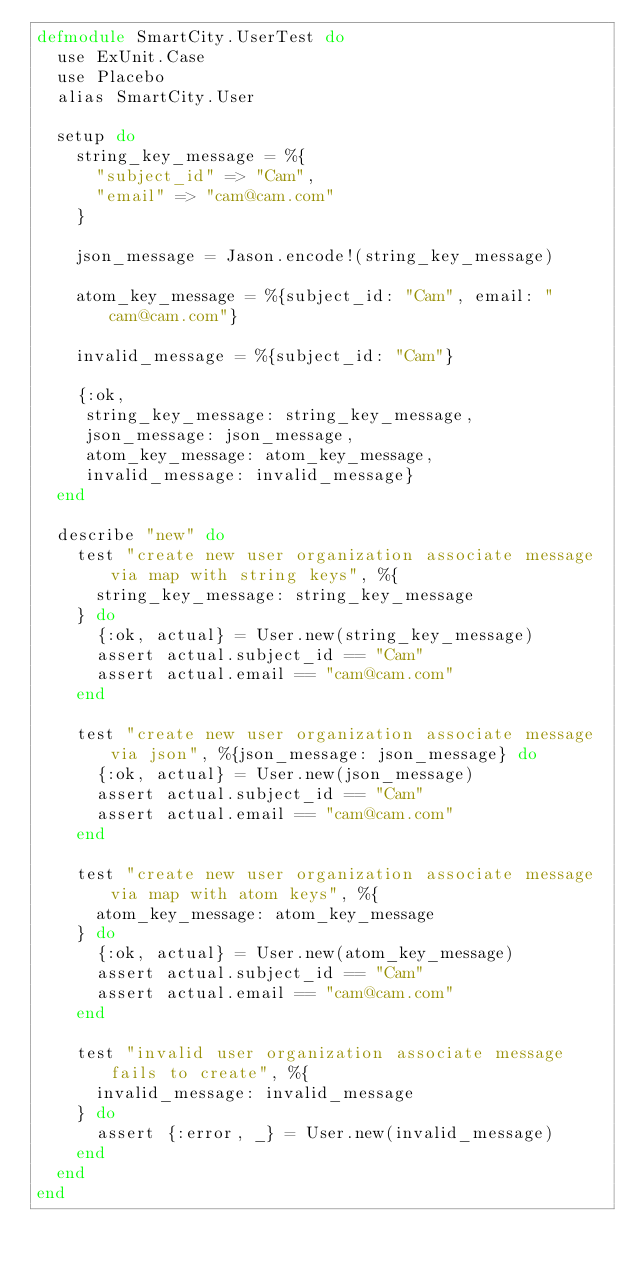Convert code to text. <code><loc_0><loc_0><loc_500><loc_500><_Elixir_>defmodule SmartCity.UserTest do
  use ExUnit.Case
  use Placebo
  alias SmartCity.User

  setup do
    string_key_message = %{
      "subject_id" => "Cam",
      "email" => "cam@cam.com"
    }

    json_message = Jason.encode!(string_key_message)

    atom_key_message = %{subject_id: "Cam", email: "cam@cam.com"}

    invalid_message = %{subject_id: "Cam"}

    {:ok,
     string_key_message: string_key_message,
     json_message: json_message,
     atom_key_message: atom_key_message,
     invalid_message: invalid_message}
  end

  describe "new" do
    test "create new user organization associate message via map with string keys", %{
      string_key_message: string_key_message
    } do
      {:ok, actual} = User.new(string_key_message)
      assert actual.subject_id == "Cam"
      assert actual.email == "cam@cam.com"
    end

    test "create new user organization associate message via json", %{json_message: json_message} do
      {:ok, actual} = User.new(json_message)
      assert actual.subject_id == "Cam"
      assert actual.email == "cam@cam.com"
    end

    test "create new user organization associate message via map with atom keys", %{
      atom_key_message: atom_key_message
    } do
      {:ok, actual} = User.new(atom_key_message)
      assert actual.subject_id == "Cam"
      assert actual.email == "cam@cam.com"
    end

    test "invalid user organization associate message fails to create", %{
      invalid_message: invalid_message
    } do
      assert {:error, _} = User.new(invalid_message)
    end
  end
end
</code> 